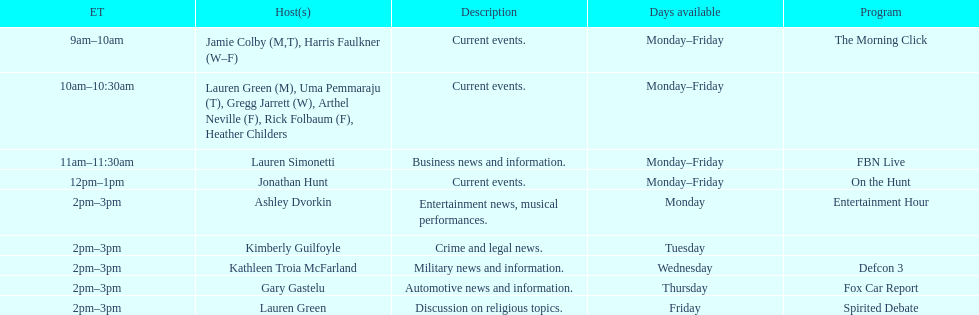Tell me the number of shows that only have one host per day. 7. 